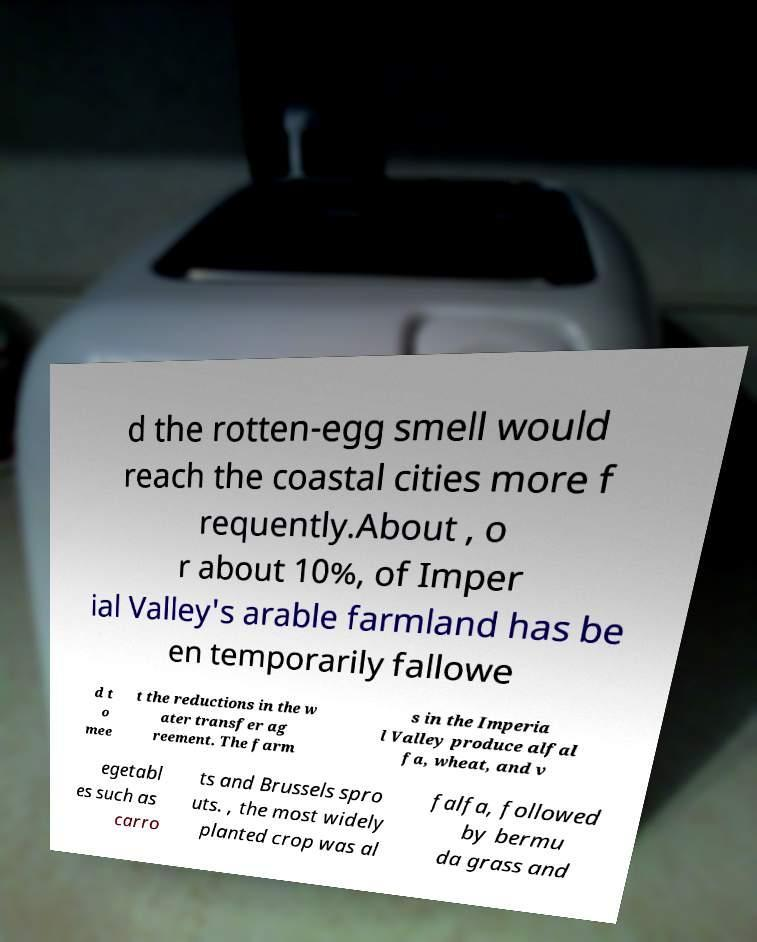Please read and relay the text visible in this image. What does it say? d the rotten-egg smell would reach the coastal cities more f requently.About , o r about 10%, of Imper ial Valley's arable farmland has be en temporarily fallowe d t o mee t the reductions in the w ater transfer ag reement. The farm s in the Imperia l Valley produce alfal fa, wheat, and v egetabl es such as carro ts and Brussels spro uts. , the most widely planted crop was al falfa, followed by bermu da grass and 